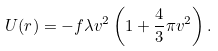Convert formula to latex. <formula><loc_0><loc_0><loc_500><loc_500>U ( r ) = - f \lambda v ^ { 2 } \left ( 1 + \frac { 4 } { 3 } \pi v ^ { 2 } \right ) .</formula> 